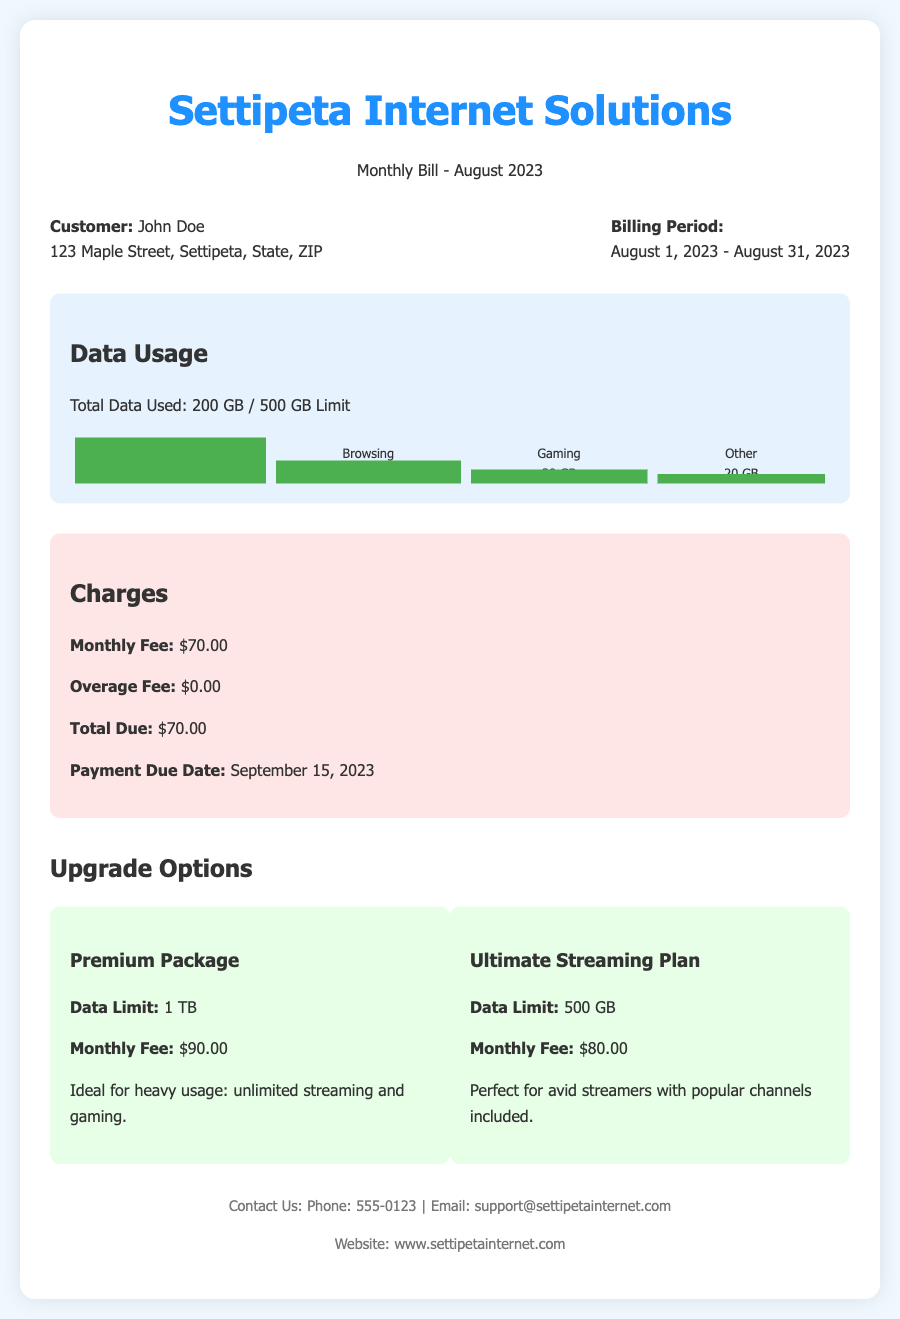What is the total data used? The total data used is specified in the document as part of the data usage section.
Answer: 200 GB What is the data limit for the Premium Package? The data limit for the Premium Package is indicated in the upgrade options section.
Answer: 1 TB How much is the monthly fee? The monthly fee is listed as part of the charges section in the document.
Answer: $70.00 When is the payment due date? The payment due date is stated in the charges section of the document.
Answer: September 15, 2023 What percentage of the data limit was used for streaming? The usage section shows the distribution of data usage based on activities, specifically for streaming.
Answer: 100% What is the monthly fee for the Ultimate Streaming Plan? The fee for the Ultimate Streaming Plan can be found in the upgrade options section.
Answer: $80.00 How many gigabytes were used for gaming? The gaming data usage is specified in the usage section of the document.
Answer: 30 GB Which upgrade option is ideal for heavy usage? The ideal upgrade for heavy usage is described in the upgrade options section.
Answer: Premium Package What is the total due amount? The total due amount is detailed in the charges section of the document.
Answer: $70.00 